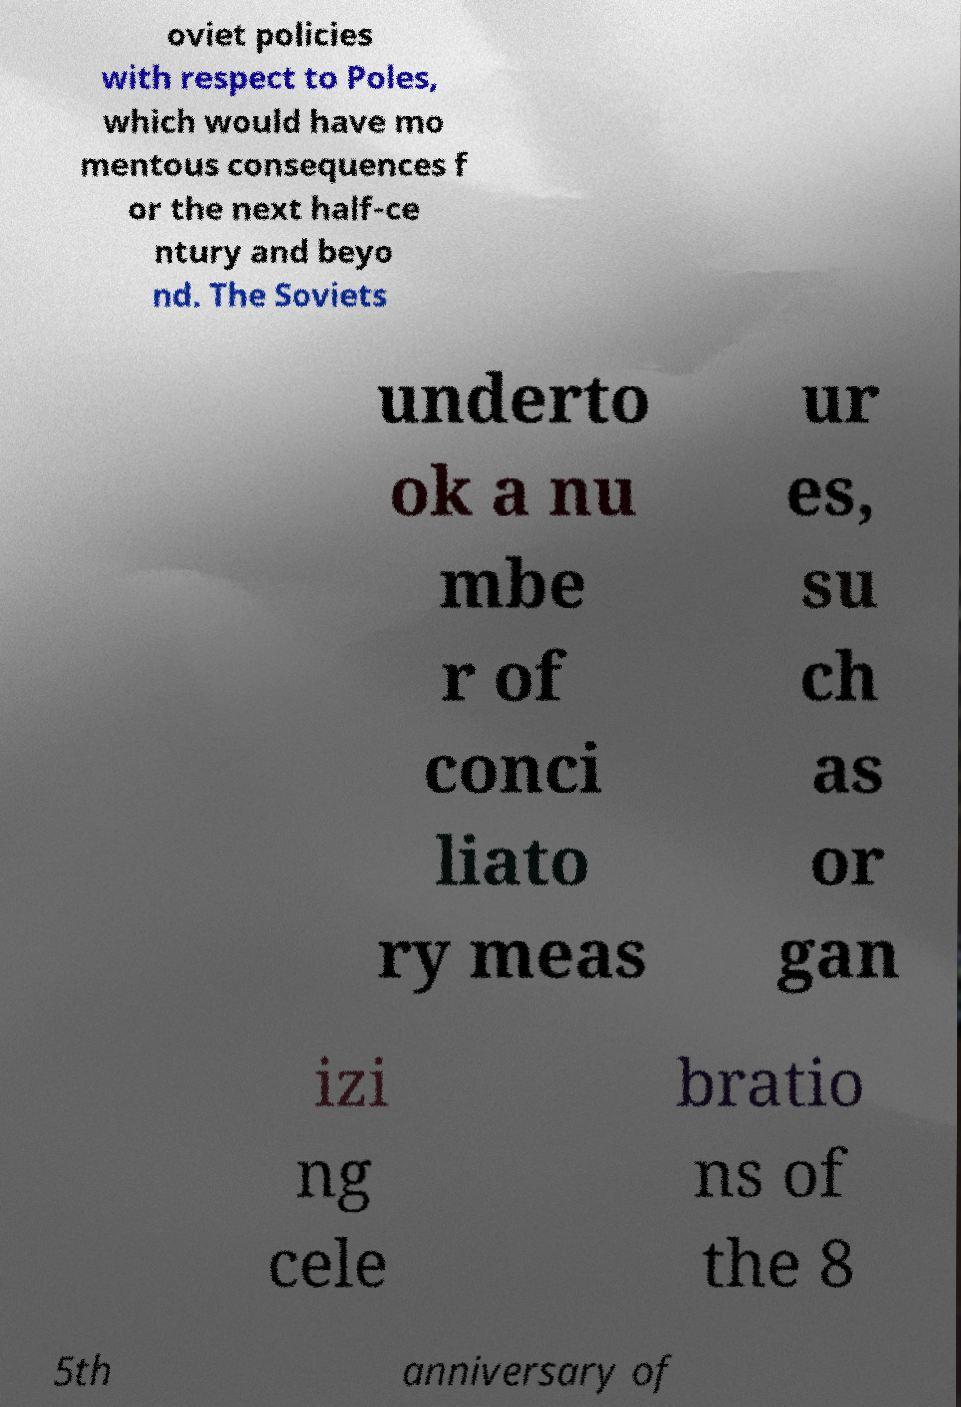There's text embedded in this image that I need extracted. Can you transcribe it verbatim? oviet policies with respect to Poles, which would have mo mentous consequences f or the next half-ce ntury and beyo nd. The Soviets underto ok a nu mbe r of conci liato ry meas ur es, su ch as or gan izi ng cele bratio ns of the 8 5th anniversary of 